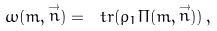<formula> <loc_0><loc_0><loc_500><loc_500>\omega ( m , \stackrel { \rightarrow } { n } ) = \ t r ( \rho _ { 1 } \Pi ( m , \stackrel { \rightarrow } { n } ) ) \, ,</formula> 